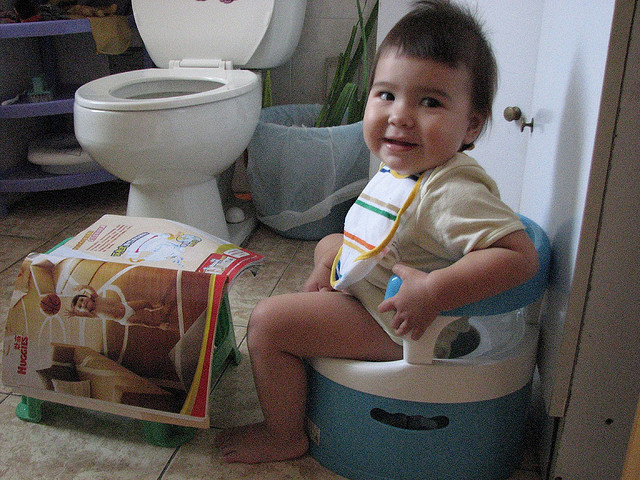<image>What part of the newspaper is the baby looking at? I am not sure what part of the newspaper the baby is looking at. It could be the ads or advertisement section. What part of the newspaper is the baby looking at? I don't know what part of the newspaper the baby is looking at. It could be the ads, diaper ad, kids section, or the advertising section. 